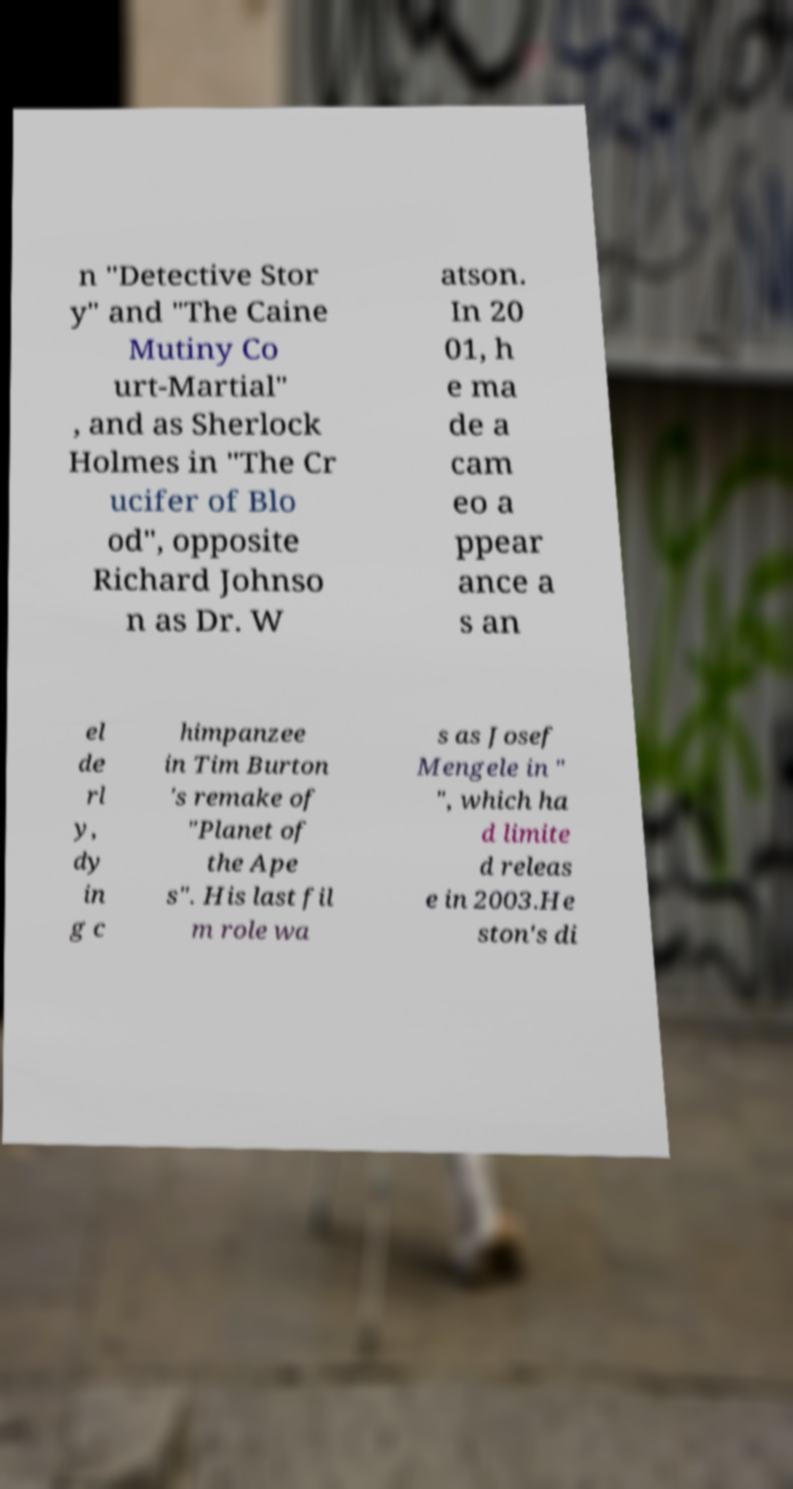For documentation purposes, I need the text within this image transcribed. Could you provide that? n "Detective Stor y" and "The Caine Mutiny Co urt-Martial" , and as Sherlock Holmes in "The Cr ucifer of Blo od", opposite Richard Johnso n as Dr. W atson. In 20 01, h e ma de a cam eo a ppear ance a s an el de rl y, dy in g c himpanzee in Tim Burton 's remake of "Planet of the Ape s". His last fil m role wa s as Josef Mengele in " ", which ha d limite d releas e in 2003.He ston's di 